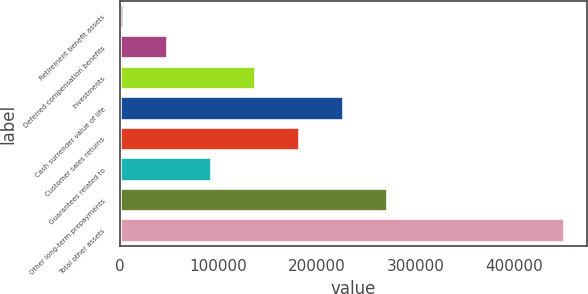<chart> <loc_0><loc_0><loc_500><loc_500><bar_chart><fcel>Retirement benefit assets<fcel>Deferred compensation benefits<fcel>Investments<fcel>Cash surrender value of life<fcel>Customer sales returns<fcel>Guarantees related to<fcel>Other long-term prepayments<fcel>Total other assets<nl><fcel>4247<fcel>48991.3<fcel>138480<fcel>227968<fcel>183224<fcel>93735.6<fcel>272713<fcel>451690<nl></chart> 